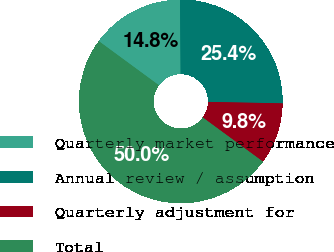<chart> <loc_0><loc_0><loc_500><loc_500><pie_chart><fcel>Quarterly market performance<fcel>Annual review / assumption<fcel>Quarterly adjustment for<fcel>Total<nl><fcel>14.8%<fcel>25.43%<fcel>9.77%<fcel>50.0%<nl></chart> 